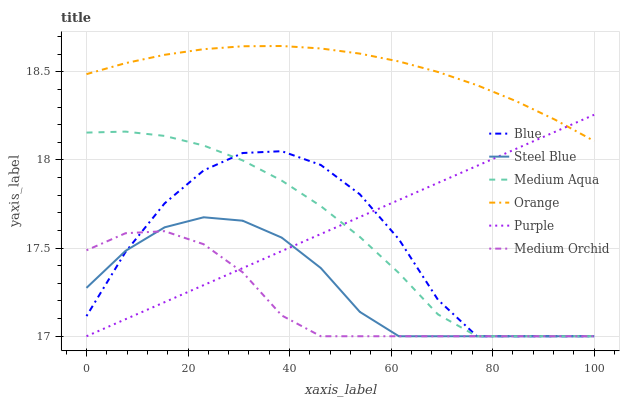Does Purple have the minimum area under the curve?
Answer yes or no. No. Does Purple have the maximum area under the curve?
Answer yes or no. No. Is Medium Orchid the smoothest?
Answer yes or no. No. Is Medium Orchid the roughest?
Answer yes or no. No. Does Orange have the lowest value?
Answer yes or no. No. Does Purple have the highest value?
Answer yes or no. No. Is Steel Blue less than Orange?
Answer yes or no. Yes. Is Orange greater than Medium Orchid?
Answer yes or no. Yes. Does Steel Blue intersect Orange?
Answer yes or no. No. 